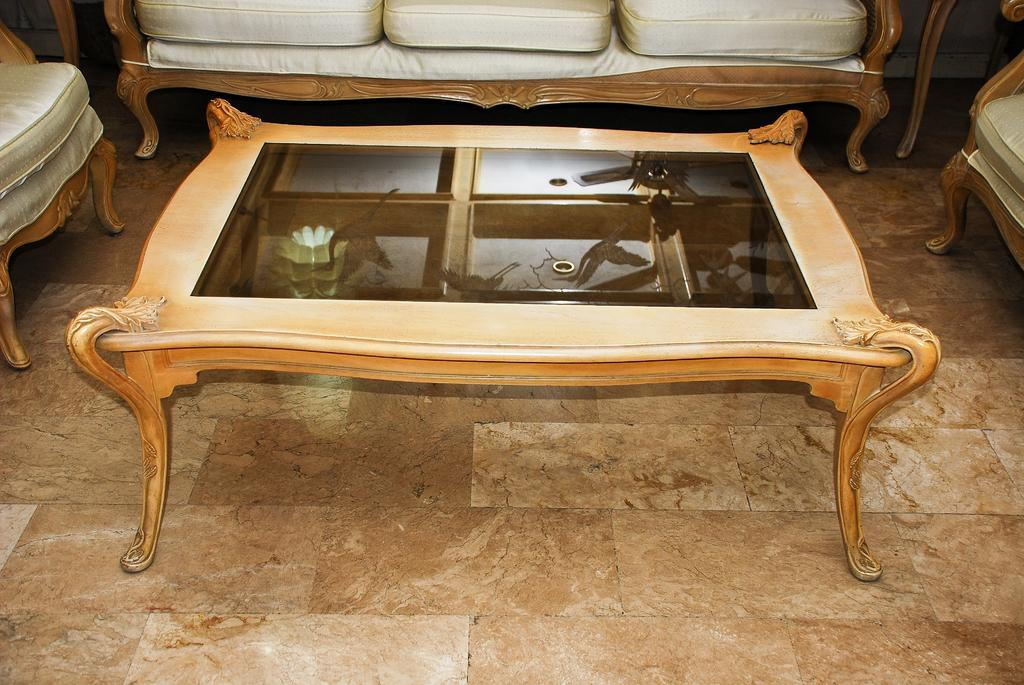What type of table is in the image? There is a wooden glass table in the image. Where is the table located in relation to the room? The table is on the floor at the center. What type of seating is in the image? There is a sofa in the image. How many sofas are in the image? There are two sofas in the image. Where are the sofas placed in the room? One sofa is placed on the left side, and the other is placed on the right side. What type of soda is being served on the wooden glass table in the image? There is no soda present in the image; it only features a table and sofas. Can you see a wren perched on one of the sofas in the image? There is no wren present in the image; it only features a table and sofas. 